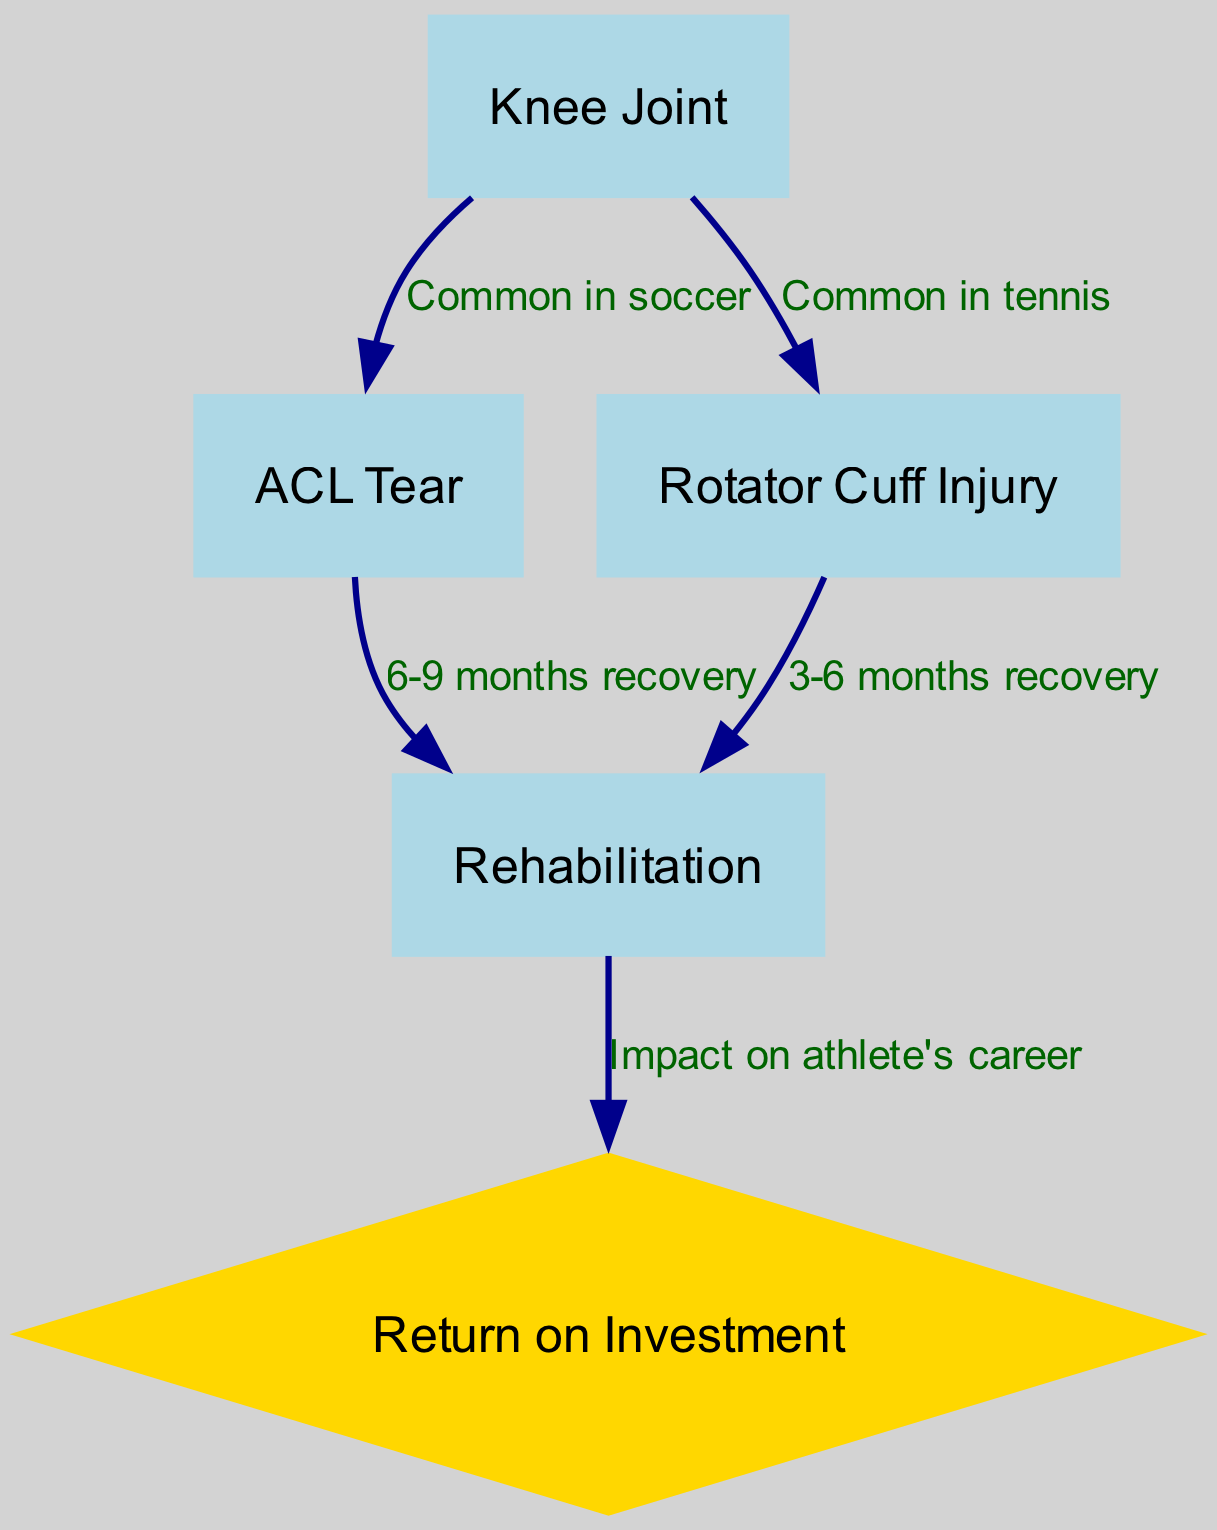What is the first node in the diagram? The first node listed in the data is "Knee Joint", which is represented with an index of "1" in the node list.
Answer: Knee Joint How many injuries are represented in the diagram? There are two injuries represented in the diagram: "ACL Tear" and "Rotator Cuff Injury", indicated by the IDs "2" and "3".
Answer: 2 What is the recovery timeline for an ACL Tear? The diagram specifies that the recovery timeline for an ACL Tear is "6-9 months", which is indicated by the edge connecting the ACL Tear to Rehabilitation.
Answer: 6-9 months Which sport is associated with the Rotator Cuff Injury? The diagram indicates that the Rotator Cuff Injury is common in "tennis", as shown by the directed edge from the "Knee Joint" to "Rotator Cuff Injury" with the label.
Answer: tennis What is the direct impact of Rehabilitation on an athlete's career? The edge connecting Rehabilitation to Return on Investment states "Impact on athlete's career", indicating that Rehabilitation has a significant impact on returning to an athletic career.
Answer: Impact on athlete's career Which injury has a shorter recovery timeline? Comparing the recovery timelines, "Rotator Cuff Injury" has a shorter timeline of "3-6 months" compared to "ACL Tear", which has "6-9 months".
Answer: Rotator Cuff Injury What color is used to represent the Return on Investment node? The Return on Investment node is represented in a "gold" color, as it is styled differently from the other nodes in the diagram.
Answer: gold How many edges are in the diagram? The diagram specifies that there are five edges connecting the nodes, each representing relationships between injuries and rehabilitation.
Answer: 5 What relationship does the "Knee Joint" have with "ACL Tear"? The relationship indicated by the edge between the "Knee Joint" and "ACL Tear" specifies that ACL tears are "Common in soccer".
Answer: Common in soccer 